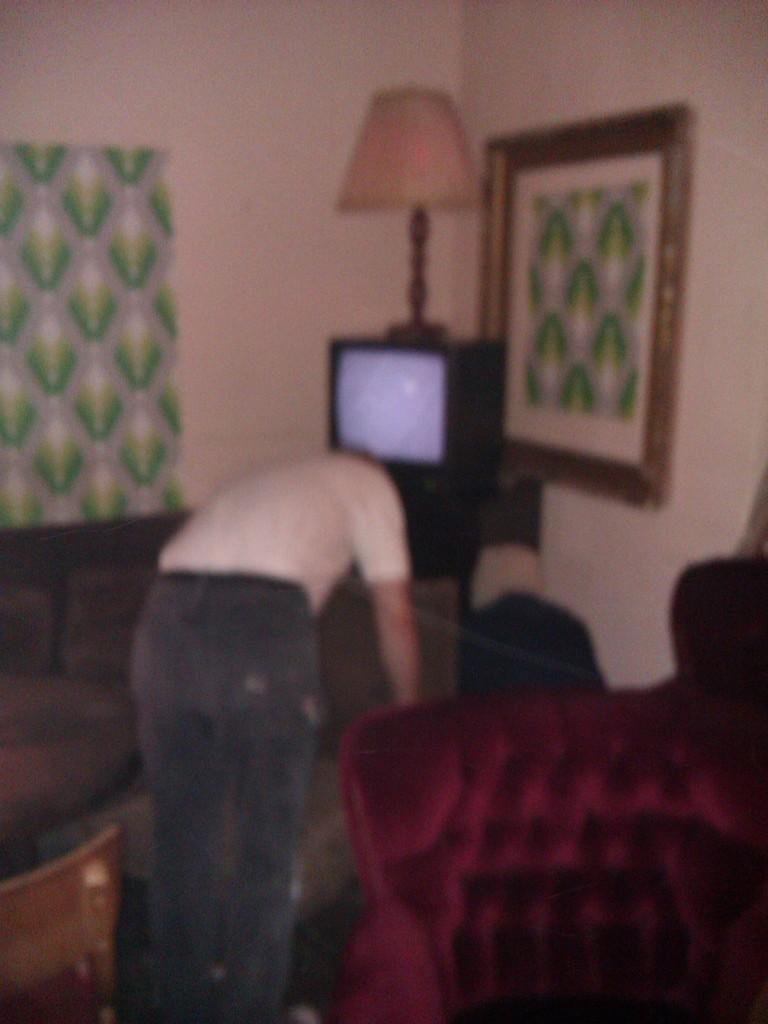How would you summarize this image in a sentence or two? This is the picture of a room. In this image there is a person standing. In the foreground there is a chair. On the right and on the left side of the image there are chairs. At the back there is a television on the table and there is a lamp on the television. There is a frame on the wall and there is a curtain 